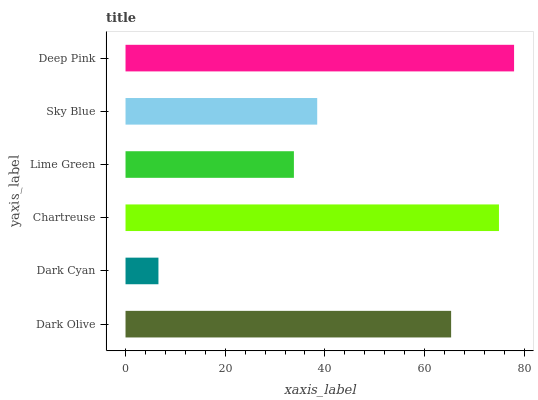Is Dark Cyan the minimum?
Answer yes or no. Yes. Is Deep Pink the maximum?
Answer yes or no. Yes. Is Chartreuse the minimum?
Answer yes or no. No. Is Chartreuse the maximum?
Answer yes or no. No. Is Chartreuse greater than Dark Cyan?
Answer yes or no. Yes. Is Dark Cyan less than Chartreuse?
Answer yes or no. Yes. Is Dark Cyan greater than Chartreuse?
Answer yes or no. No. Is Chartreuse less than Dark Cyan?
Answer yes or no. No. Is Dark Olive the high median?
Answer yes or no. Yes. Is Sky Blue the low median?
Answer yes or no. Yes. Is Chartreuse the high median?
Answer yes or no. No. Is Lime Green the low median?
Answer yes or no. No. 